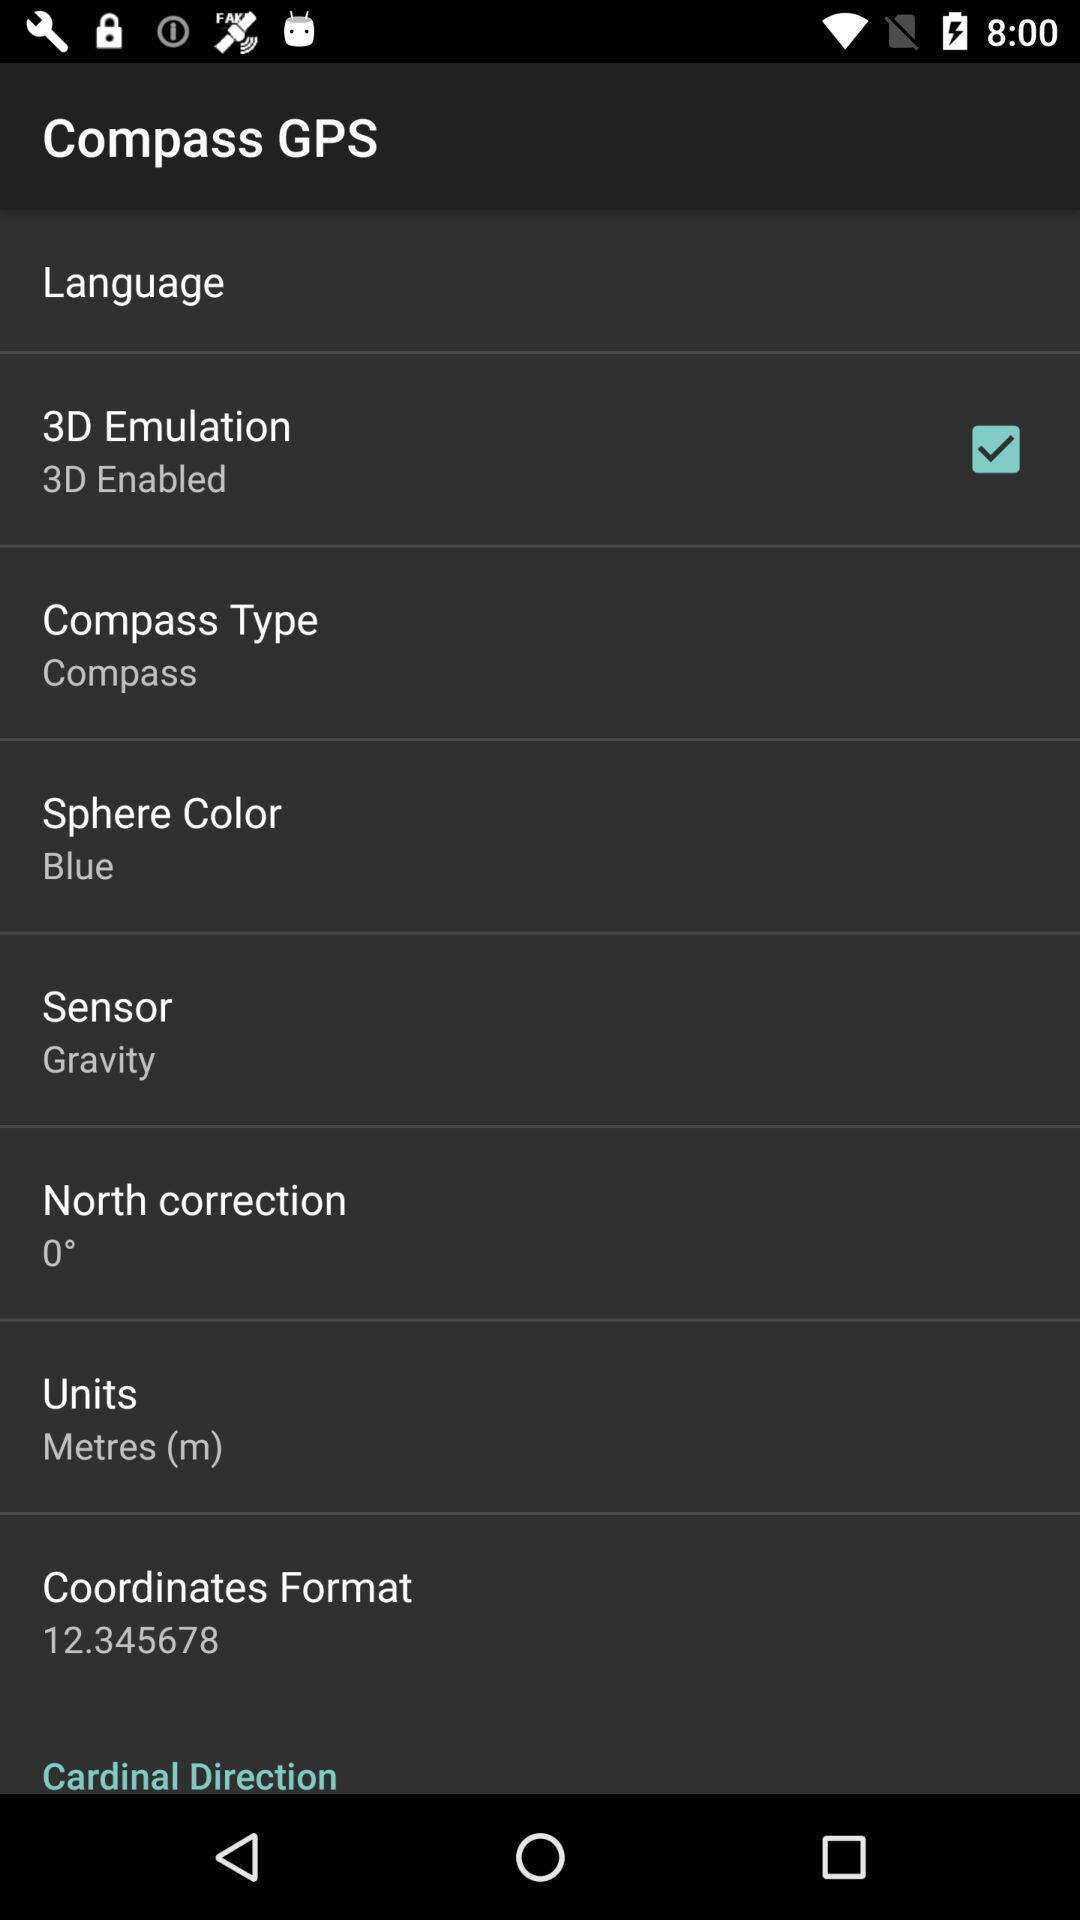What is the altitude? The altitude is 207 meters. 